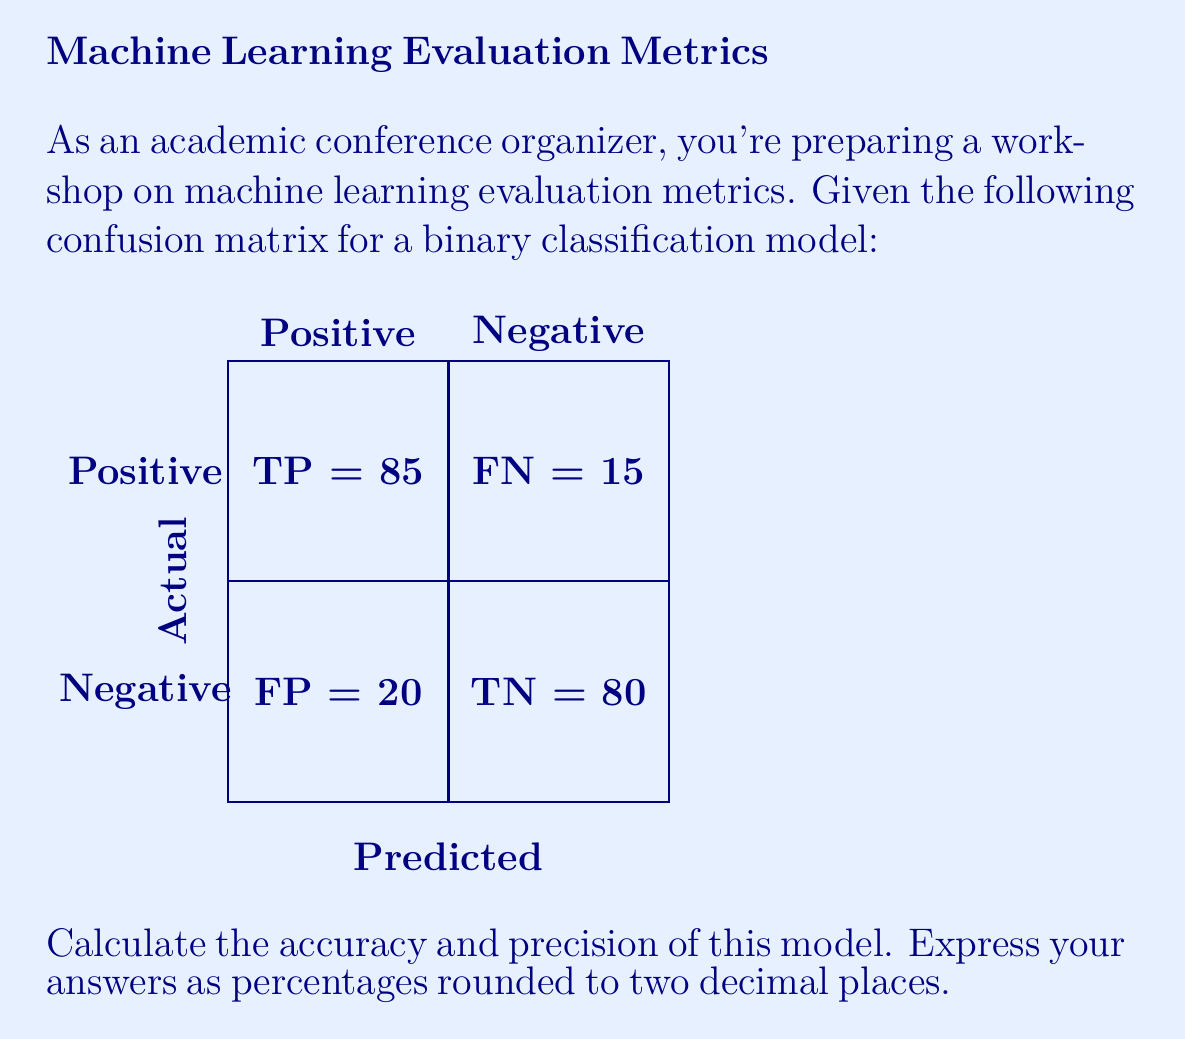Help me with this question. Let's approach this step-by-step:

1) First, let's recall the formulas for accuracy and precision:

   Accuracy = $\frac{\text{TP} + \text{TN}}{\text{TP} + \text{TN} + \text{FP} + \text{FN}}$

   Precision = $\frac{\text{TP}}{\text{TP} + \text{FP}}$

   Where TP = True Positives, TN = True Negatives, FP = False Positives, FN = False Negatives

2) From the confusion matrix, we can identify:
   TP = 85, TN = 80, FP = 20, FN = 15

3) Let's calculate accuracy:
   
   Accuracy = $\frac{85 + 80}{85 + 80 + 20 + 15} = \frac{165}{200} = 0.825$

   As a percentage: $0.825 \times 100\% = 82.50\%$

4) Now, let's calculate precision:

   Precision = $\frac{85}{85 + 20} = \frac{85}{105} \approx 0.8095$

   As a percentage: $0.8095 \times 100\% \approx 80.95\%$

5) Rounding both to two decimal places:
   Accuracy: 82.50%
   Precision: 80.95%
Answer: Accuracy: 82.50%, Precision: 80.95% 